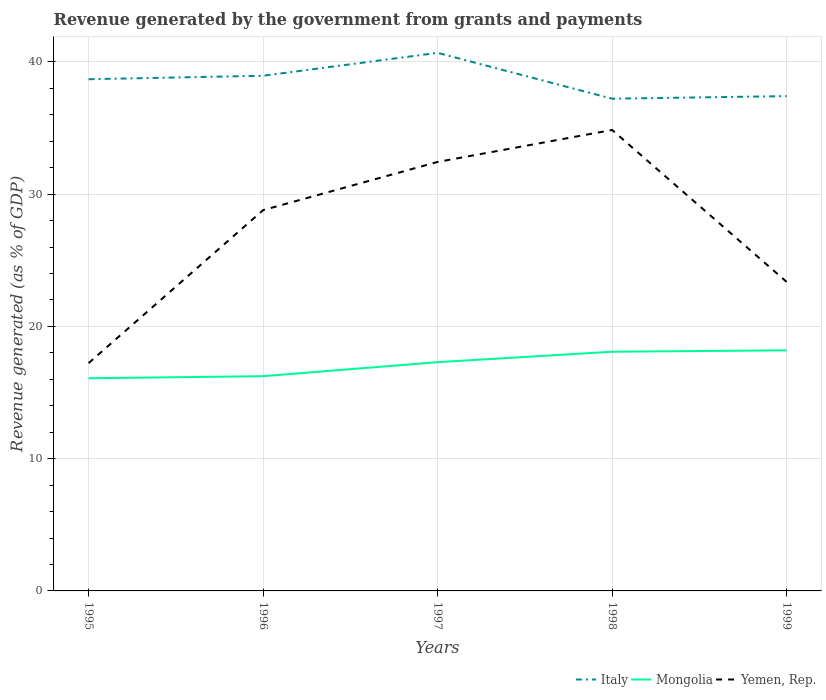Is the number of lines equal to the number of legend labels?
Offer a terse response. Yes. Across all years, what is the maximum revenue generated by the government in Mongolia?
Your answer should be very brief. 16.08. In which year was the revenue generated by the government in Italy maximum?
Your answer should be compact. 1998. What is the total revenue generated by the government in Mongolia in the graph?
Your response must be concise. -1.06. What is the difference between the highest and the second highest revenue generated by the government in Yemen, Rep.?
Your answer should be compact. 17.63. How many lines are there?
Your answer should be very brief. 3. How many years are there in the graph?
Offer a very short reply. 5. What is the difference between two consecutive major ticks on the Y-axis?
Provide a succinct answer. 10. Are the values on the major ticks of Y-axis written in scientific E-notation?
Keep it short and to the point. No. How many legend labels are there?
Offer a very short reply. 3. What is the title of the graph?
Your response must be concise. Revenue generated by the government from grants and payments. What is the label or title of the X-axis?
Ensure brevity in your answer.  Years. What is the label or title of the Y-axis?
Your response must be concise. Revenue generated (as % of GDP). What is the Revenue generated (as % of GDP) in Italy in 1995?
Give a very brief answer. 38.69. What is the Revenue generated (as % of GDP) in Mongolia in 1995?
Your response must be concise. 16.08. What is the Revenue generated (as % of GDP) in Yemen, Rep. in 1995?
Keep it short and to the point. 17.22. What is the Revenue generated (as % of GDP) in Italy in 1996?
Make the answer very short. 38.95. What is the Revenue generated (as % of GDP) of Mongolia in 1996?
Keep it short and to the point. 16.24. What is the Revenue generated (as % of GDP) in Yemen, Rep. in 1996?
Provide a succinct answer. 28.79. What is the Revenue generated (as % of GDP) of Italy in 1997?
Give a very brief answer. 40.68. What is the Revenue generated (as % of GDP) in Mongolia in 1997?
Provide a short and direct response. 17.3. What is the Revenue generated (as % of GDP) of Yemen, Rep. in 1997?
Offer a terse response. 32.44. What is the Revenue generated (as % of GDP) of Italy in 1998?
Offer a terse response. 37.22. What is the Revenue generated (as % of GDP) in Mongolia in 1998?
Provide a short and direct response. 18.08. What is the Revenue generated (as % of GDP) of Yemen, Rep. in 1998?
Offer a terse response. 34.85. What is the Revenue generated (as % of GDP) in Italy in 1999?
Provide a short and direct response. 37.41. What is the Revenue generated (as % of GDP) of Mongolia in 1999?
Provide a short and direct response. 18.19. What is the Revenue generated (as % of GDP) of Yemen, Rep. in 1999?
Provide a succinct answer. 23.37. Across all years, what is the maximum Revenue generated (as % of GDP) in Italy?
Your response must be concise. 40.68. Across all years, what is the maximum Revenue generated (as % of GDP) in Mongolia?
Offer a very short reply. 18.19. Across all years, what is the maximum Revenue generated (as % of GDP) in Yemen, Rep.?
Offer a very short reply. 34.85. Across all years, what is the minimum Revenue generated (as % of GDP) in Italy?
Provide a succinct answer. 37.22. Across all years, what is the minimum Revenue generated (as % of GDP) of Mongolia?
Keep it short and to the point. 16.08. Across all years, what is the minimum Revenue generated (as % of GDP) in Yemen, Rep.?
Your answer should be compact. 17.22. What is the total Revenue generated (as % of GDP) of Italy in the graph?
Your response must be concise. 192.96. What is the total Revenue generated (as % of GDP) in Mongolia in the graph?
Ensure brevity in your answer.  85.89. What is the total Revenue generated (as % of GDP) of Yemen, Rep. in the graph?
Provide a succinct answer. 136.67. What is the difference between the Revenue generated (as % of GDP) of Italy in 1995 and that in 1996?
Offer a terse response. -0.26. What is the difference between the Revenue generated (as % of GDP) of Mongolia in 1995 and that in 1996?
Your answer should be compact. -0.16. What is the difference between the Revenue generated (as % of GDP) in Yemen, Rep. in 1995 and that in 1996?
Your response must be concise. -11.57. What is the difference between the Revenue generated (as % of GDP) of Italy in 1995 and that in 1997?
Provide a succinct answer. -1.99. What is the difference between the Revenue generated (as % of GDP) of Mongolia in 1995 and that in 1997?
Your response must be concise. -1.22. What is the difference between the Revenue generated (as % of GDP) of Yemen, Rep. in 1995 and that in 1997?
Provide a succinct answer. -15.21. What is the difference between the Revenue generated (as % of GDP) in Italy in 1995 and that in 1998?
Make the answer very short. 1.47. What is the difference between the Revenue generated (as % of GDP) of Mongolia in 1995 and that in 1998?
Your answer should be very brief. -2.01. What is the difference between the Revenue generated (as % of GDP) in Yemen, Rep. in 1995 and that in 1998?
Keep it short and to the point. -17.63. What is the difference between the Revenue generated (as % of GDP) of Italy in 1995 and that in 1999?
Keep it short and to the point. 1.28. What is the difference between the Revenue generated (as % of GDP) in Mongolia in 1995 and that in 1999?
Keep it short and to the point. -2.11. What is the difference between the Revenue generated (as % of GDP) in Yemen, Rep. in 1995 and that in 1999?
Provide a short and direct response. -6.14. What is the difference between the Revenue generated (as % of GDP) of Italy in 1996 and that in 1997?
Your answer should be very brief. -1.73. What is the difference between the Revenue generated (as % of GDP) of Mongolia in 1996 and that in 1997?
Offer a terse response. -1.06. What is the difference between the Revenue generated (as % of GDP) in Yemen, Rep. in 1996 and that in 1997?
Ensure brevity in your answer.  -3.64. What is the difference between the Revenue generated (as % of GDP) of Italy in 1996 and that in 1998?
Your answer should be compact. 1.73. What is the difference between the Revenue generated (as % of GDP) of Mongolia in 1996 and that in 1998?
Provide a short and direct response. -1.85. What is the difference between the Revenue generated (as % of GDP) of Yemen, Rep. in 1996 and that in 1998?
Make the answer very short. -6.06. What is the difference between the Revenue generated (as % of GDP) of Italy in 1996 and that in 1999?
Provide a short and direct response. 1.54. What is the difference between the Revenue generated (as % of GDP) in Mongolia in 1996 and that in 1999?
Give a very brief answer. -1.95. What is the difference between the Revenue generated (as % of GDP) in Yemen, Rep. in 1996 and that in 1999?
Your answer should be compact. 5.42. What is the difference between the Revenue generated (as % of GDP) of Italy in 1997 and that in 1998?
Your answer should be compact. 3.47. What is the difference between the Revenue generated (as % of GDP) in Mongolia in 1997 and that in 1998?
Make the answer very short. -0.79. What is the difference between the Revenue generated (as % of GDP) of Yemen, Rep. in 1997 and that in 1998?
Your answer should be very brief. -2.42. What is the difference between the Revenue generated (as % of GDP) of Italy in 1997 and that in 1999?
Keep it short and to the point. 3.27. What is the difference between the Revenue generated (as % of GDP) in Mongolia in 1997 and that in 1999?
Keep it short and to the point. -0.9. What is the difference between the Revenue generated (as % of GDP) of Yemen, Rep. in 1997 and that in 1999?
Your answer should be very brief. 9.07. What is the difference between the Revenue generated (as % of GDP) of Italy in 1998 and that in 1999?
Your response must be concise. -0.19. What is the difference between the Revenue generated (as % of GDP) in Mongolia in 1998 and that in 1999?
Provide a succinct answer. -0.11. What is the difference between the Revenue generated (as % of GDP) in Yemen, Rep. in 1998 and that in 1999?
Your answer should be compact. 11.48. What is the difference between the Revenue generated (as % of GDP) in Italy in 1995 and the Revenue generated (as % of GDP) in Mongolia in 1996?
Make the answer very short. 22.45. What is the difference between the Revenue generated (as % of GDP) of Italy in 1995 and the Revenue generated (as % of GDP) of Yemen, Rep. in 1996?
Provide a succinct answer. 9.9. What is the difference between the Revenue generated (as % of GDP) in Mongolia in 1995 and the Revenue generated (as % of GDP) in Yemen, Rep. in 1996?
Your answer should be very brief. -12.71. What is the difference between the Revenue generated (as % of GDP) in Italy in 1995 and the Revenue generated (as % of GDP) in Mongolia in 1997?
Keep it short and to the point. 21.39. What is the difference between the Revenue generated (as % of GDP) in Italy in 1995 and the Revenue generated (as % of GDP) in Yemen, Rep. in 1997?
Your response must be concise. 6.25. What is the difference between the Revenue generated (as % of GDP) in Mongolia in 1995 and the Revenue generated (as % of GDP) in Yemen, Rep. in 1997?
Your response must be concise. -16.36. What is the difference between the Revenue generated (as % of GDP) of Italy in 1995 and the Revenue generated (as % of GDP) of Mongolia in 1998?
Ensure brevity in your answer.  20.6. What is the difference between the Revenue generated (as % of GDP) in Italy in 1995 and the Revenue generated (as % of GDP) in Yemen, Rep. in 1998?
Provide a succinct answer. 3.84. What is the difference between the Revenue generated (as % of GDP) of Mongolia in 1995 and the Revenue generated (as % of GDP) of Yemen, Rep. in 1998?
Provide a succinct answer. -18.77. What is the difference between the Revenue generated (as % of GDP) of Italy in 1995 and the Revenue generated (as % of GDP) of Mongolia in 1999?
Give a very brief answer. 20.5. What is the difference between the Revenue generated (as % of GDP) in Italy in 1995 and the Revenue generated (as % of GDP) in Yemen, Rep. in 1999?
Provide a succinct answer. 15.32. What is the difference between the Revenue generated (as % of GDP) in Mongolia in 1995 and the Revenue generated (as % of GDP) in Yemen, Rep. in 1999?
Your response must be concise. -7.29. What is the difference between the Revenue generated (as % of GDP) of Italy in 1996 and the Revenue generated (as % of GDP) of Mongolia in 1997?
Offer a terse response. 21.66. What is the difference between the Revenue generated (as % of GDP) of Italy in 1996 and the Revenue generated (as % of GDP) of Yemen, Rep. in 1997?
Ensure brevity in your answer.  6.52. What is the difference between the Revenue generated (as % of GDP) in Mongolia in 1996 and the Revenue generated (as % of GDP) in Yemen, Rep. in 1997?
Your response must be concise. -16.2. What is the difference between the Revenue generated (as % of GDP) in Italy in 1996 and the Revenue generated (as % of GDP) in Mongolia in 1998?
Provide a succinct answer. 20.87. What is the difference between the Revenue generated (as % of GDP) of Italy in 1996 and the Revenue generated (as % of GDP) of Yemen, Rep. in 1998?
Ensure brevity in your answer.  4.1. What is the difference between the Revenue generated (as % of GDP) of Mongolia in 1996 and the Revenue generated (as % of GDP) of Yemen, Rep. in 1998?
Give a very brief answer. -18.62. What is the difference between the Revenue generated (as % of GDP) in Italy in 1996 and the Revenue generated (as % of GDP) in Mongolia in 1999?
Your answer should be very brief. 20.76. What is the difference between the Revenue generated (as % of GDP) of Italy in 1996 and the Revenue generated (as % of GDP) of Yemen, Rep. in 1999?
Offer a terse response. 15.58. What is the difference between the Revenue generated (as % of GDP) of Mongolia in 1996 and the Revenue generated (as % of GDP) of Yemen, Rep. in 1999?
Your response must be concise. -7.13. What is the difference between the Revenue generated (as % of GDP) of Italy in 1997 and the Revenue generated (as % of GDP) of Mongolia in 1998?
Offer a very short reply. 22.6. What is the difference between the Revenue generated (as % of GDP) of Italy in 1997 and the Revenue generated (as % of GDP) of Yemen, Rep. in 1998?
Your answer should be very brief. 5.83. What is the difference between the Revenue generated (as % of GDP) of Mongolia in 1997 and the Revenue generated (as % of GDP) of Yemen, Rep. in 1998?
Keep it short and to the point. -17.56. What is the difference between the Revenue generated (as % of GDP) of Italy in 1997 and the Revenue generated (as % of GDP) of Mongolia in 1999?
Your answer should be compact. 22.49. What is the difference between the Revenue generated (as % of GDP) in Italy in 1997 and the Revenue generated (as % of GDP) in Yemen, Rep. in 1999?
Provide a succinct answer. 17.32. What is the difference between the Revenue generated (as % of GDP) of Mongolia in 1997 and the Revenue generated (as % of GDP) of Yemen, Rep. in 1999?
Keep it short and to the point. -6.07. What is the difference between the Revenue generated (as % of GDP) of Italy in 1998 and the Revenue generated (as % of GDP) of Mongolia in 1999?
Offer a terse response. 19.03. What is the difference between the Revenue generated (as % of GDP) of Italy in 1998 and the Revenue generated (as % of GDP) of Yemen, Rep. in 1999?
Provide a short and direct response. 13.85. What is the difference between the Revenue generated (as % of GDP) of Mongolia in 1998 and the Revenue generated (as % of GDP) of Yemen, Rep. in 1999?
Provide a succinct answer. -5.28. What is the average Revenue generated (as % of GDP) of Italy per year?
Your answer should be very brief. 38.59. What is the average Revenue generated (as % of GDP) in Mongolia per year?
Keep it short and to the point. 17.18. What is the average Revenue generated (as % of GDP) in Yemen, Rep. per year?
Your response must be concise. 27.33. In the year 1995, what is the difference between the Revenue generated (as % of GDP) of Italy and Revenue generated (as % of GDP) of Mongolia?
Your answer should be very brief. 22.61. In the year 1995, what is the difference between the Revenue generated (as % of GDP) in Italy and Revenue generated (as % of GDP) in Yemen, Rep.?
Keep it short and to the point. 21.46. In the year 1995, what is the difference between the Revenue generated (as % of GDP) of Mongolia and Revenue generated (as % of GDP) of Yemen, Rep.?
Your answer should be very brief. -1.15. In the year 1996, what is the difference between the Revenue generated (as % of GDP) of Italy and Revenue generated (as % of GDP) of Mongolia?
Provide a succinct answer. 22.71. In the year 1996, what is the difference between the Revenue generated (as % of GDP) in Italy and Revenue generated (as % of GDP) in Yemen, Rep.?
Provide a succinct answer. 10.16. In the year 1996, what is the difference between the Revenue generated (as % of GDP) in Mongolia and Revenue generated (as % of GDP) in Yemen, Rep.?
Offer a terse response. -12.55. In the year 1997, what is the difference between the Revenue generated (as % of GDP) in Italy and Revenue generated (as % of GDP) in Mongolia?
Ensure brevity in your answer.  23.39. In the year 1997, what is the difference between the Revenue generated (as % of GDP) of Italy and Revenue generated (as % of GDP) of Yemen, Rep.?
Provide a short and direct response. 8.25. In the year 1997, what is the difference between the Revenue generated (as % of GDP) of Mongolia and Revenue generated (as % of GDP) of Yemen, Rep.?
Provide a succinct answer. -15.14. In the year 1998, what is the difference between the Revenue generated (as % of GDP) in Italy and Revenue generated (as % of GDP) in Mongolia?
Offer a terse response. 19.13. In the year 1998, what is the difference between the Revenue generated (as % of GDP) of Italy and Revenue generated (as % of GDP) of Yemen, Rep.?
Your answer should be very brief. 2.36. In the year 1998, what is the difference between the Revenue generated (as % of GDP) in Mongolia and Revenue generated (as % of GDP) in Yemen, Rep.?
Your answer should be compact. -16.77. In the year 1999, what is the difference between the Revenue generated (as % of GDP) of Italy and Revenue generated (as % of GDP) of Mongolia?
Your answer should be very brief. 19.22. In the year 1999, what is the difference between the Revenue generated (as % of GDP) in Italy and Revenue generated (as % of GDP) in Yemen, Rep.?
Offer a very short reply. 14.04. In the year 1999, what is the difference between the Revenue generated (as % of GDP) in Mongolia and Revenue generated (as % of GDP) in Yemen, Rep.?
Provide a short and direct response. -5.18. What is the ratio of the Revenue generated (as % of GDP) of Mongolia in 1995 to that in 1996?
Your answer should be compact. 0.99. What is the ratio of the Revenue generated (as % of GDP) in Yemen, Rep. in 1995 to that in 1996?
Your answer should be very brief. 0.6. What is the ratio of the Revenue generated (as % of GDP) in Italy in 1995 to that in 1997?
Your answer should be very brief. 0.95. What is the ratio of the Revenue generated (as % of GDP) in Mongolia in 1995 to that in 1997?
Provide a short and direct response. 0.93. What is the ratio of the Revenue generated (as % of GDP) in Yemen, Rep. in 1995 to that in 1997?
Your answer should be very brief. 0.53. What is the ratio of the Revenue generated (as % of GDP) in Italy in 1995 to that in 1998?
Offer a terse response. 1.04. What is the ratio of the Revenue generated (as % of GDP) of Mongolia in 1995 to that in 1998?
Your answer should be very brief. 0.89. What is the ratio of the Revenue generated (as % of GDP) of Yemen, Rep. in 1995 to that in 1998?
Your answer should be compact. 0.49. What is the ratio of the Revenue generated (as % of GDP) of Italy in 1995 to that in 1999?
Provide a succinct answer. 1.03. What is the ratio of the Revenue generated (as % of GDP) in Mongolia in 1995 to that in 1999?
Offer a terse response. 0.88. What is the ratio of the Revenue generated (as % of GDP) in Yemen, Rep. in 1995 to that in 1999?
Your answer should be very brief. 0.74. What is the ratio of the Revenue generated (as % of GDP) of Italy in 1996 to that in 1997?
Offer a terse response. 0.96. What is the ratio of the Revenue generated (as % of GDP) in Mongolia in 1996 to that in 1997?
Provide a short and direct response. 0.94. What is the ratio of the Revenue generated (as % of GDP) of Yemen, Rep. in 1996 to that in 1997?
Provide a short and direct response. 0.89. What is the ratio of the Revenue generated (as % of GDP) of Italy in 1996 to that in 1998?
Your answer should be compact. 1.05. What is the ratio of the Revenue generated (as % of GDP) of Mongolia in 1996 to that in 1998?
Your answer should be compact. 0.9. What is the ratio of the Revenue generated (as % of GDP) of Yemen, Rep. in 1996 to that in 1998?
Give a very brief answer. 0.83. What is the ratio of the Revenue generated (as % of GDP) in Italy in 1996 to that in 1999?
Your answer should be compact. 1.04. What is the ratio of the Revenue generated (as % of GDP) of Mongolia in 1996 to that in 1999?
Offer a terse response. 0.89. What is the ratio of the Revenue generated (as % of GDP) in Yemen, Rep. in 1996 to that in 1999?
Your response must be concise. 1.23. What is the ratio of the Revenue generated (as % of GDP) of Italy in 1997 to that in 1998?
Provide a succinct answer. 1.09. What is the ratio of the Revenue generated (as % of GDP) of Mongolia in 1997 to that in 1998?
Make the answer very short. 0.96. What is the ratio of the Revenue generated (as % of GDP) of Yemen, Rep. in 1997 to that in 1998?
Provide a succinct answer. 0.93. What is the ratio of the Revenue generated (as % of GDP) of Italy in 1997 to that in 1999?
Offer a very short reply. 1.09. What is the ratio of the Revenue generated (as % of GDP) in Mongolia in 1997 to that in 1999?
Your response must be concise. 0.95. What is the ratio of the Revenue generated (as % of GDP) of Yemen, Rep. in 1997 to that in 1999?
Provide a succinct answer. 1.39. What is the ratio of the Revenue generated (as % of GDP) in Yemen, Rep. in 1998 to that in 1999?
Give a very brief answer. 1.49. What is the difference between the highest and the second highest Revenue generated (as % of GDP) of Italy?
Offer a very short reply. 1.73. What is the difference between the highest and the second highest Revenue generated (as % of GDP) in Mongolia?
Your answer should be compact. 0.11. What is the difference between the highest and the second highest Revenue generated (as % of GDP) of Yemen, Rep.?
Your answer should be very brief. 2.42. What is the difference between the highest and the lowest Revenue generated (as % of GDP) of Italy?
Keep it short and to the point. 3.47. What is the difference between the highest and the lowest Revenue generated (as % of GDP) of Mongolia?
Provide a succinct answer. 2.11. What is the difference between the highest and the lowest Revenue generated (as % of GDP) in Yemen, Rep.?
Ensure brevity in your answer.  17.63. 